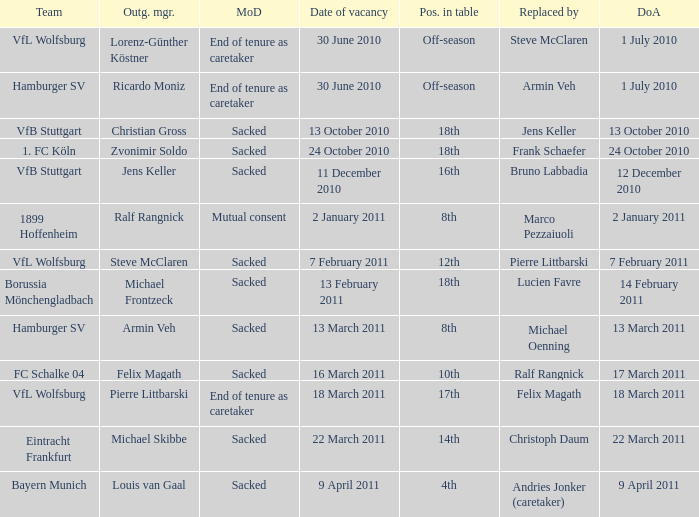When 1. fc köln is the team what is the date of appointment? 24 October 2010. 